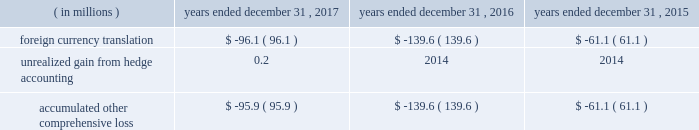Table of contents cdw corporation and subsidiaries method or straight-line method , as applicable .
The company classifies deferred financing costs as a direct deduction from the carrying value of the long-term debt liability on the consolidated balance sheets , except for deferred financing costs associated with revolving credit facilities which are presented as an asset , within other assets on the consolidated balance sheets .
Derivative instruments the company has interest rate cap agreements for the purpose of hedging its exposure to fluctuations in interest rates .
The interest rate cap agreements are designated as cash flow hedges of interest rate risk and recorded at fair value in other assets on the consolidated balance sheets .
The gain or loss on the derivative instruments is reported as a component of accumulated other comprehensive loss until reclassified to interest expense in the same period the hedge transaction affects earnings .
Fair value measurements fair value is defined under gaap as the price that would be received to sell an asset or paid to transfer a liability in an orderly transaction between market participants at the measurement date .
A fair value hierarchy has been established for valuation inputs to prioritize the inputs into three levels based on the extent to which inputs used in measuring fair value are observable in the market .
Each fair value measurement is reported in one of the three levels which is determined by the lowest level input that is significant to the fair value measurement in its entirety .
These levels are : level 1 2013 observable inputs such as quoted prices for identical instruments traded in active markets .
Level 2 2013 inputs are based on quoted prices for similar instruments in active markets , quoted prices for identical or similar instruments in markets that are not active and model-based valuation techniques for which all significant assumptions are observable in the market or can be corroborated by observable market data for substantially the full term of the assets or liabilities .
Level 3 2013 inputs are generally unobservable and typically reflect management 2019s estimates of assumptions that market participants would use in pricing the asset or liability .
The fair values are therefore determined using model-based techniques that include option pricing models , discounted cash flow models and similar techniques .
Accumulated other comprehensive loss the components of accumulated other comprehensive loss included in stockholders 2019 equity are as follows: .
Revenue recognition the company is a primary distribution channel for a large group of vendors and suppliers , including original equipment manufacturers ( 201coems 201d ) , software publishers , wholesale distributors and cloud providers .
The company records revenue from sales transactions when title and risk of loss are passed to the customer , there is persuasive evidence of an arrangement for sale , delivery has occurred and/or services have been rendered , the sales price is fixed or determinable , and collectability is reasonably assured .
The company 2019s shipping terms typically specify f.o.b .
Destination , at which time title and risk of loss have passed to the customer .
Revenues from the sales of hardware products and software licenses are generally recognized on a gross basis with the selling price to the customer recorded as sales and the acquisition cost of the product recorded as cost of sales .
These items can be delivered to customers in a variety of ways , including ( i ) as physical product shipped from the company 2019s warehouse , ( ii ) via drop-shipment by the vendor or supplier , or ( iii ) via electronic delivery for software licenses .
At the time of sale , the company records an estimate for sales returns and allowances based on historical experience .
The company 2019s vendor partners warrant most of the products the company sells .
The company leverages drop-shipment arrangements with many of its vendors and suppliers to deliver products to its customers without having to physically hold the inventory at its warehouses , thereby increasing efficiency and reducing .
In millions , what was the average loss from foreign currency translation from 2015-2017? 
Rationale: add all losses from foreign transactions and divide by the total number of years to get the average .
Computations: (((96.1 + 139.6) + 61.1) / 3)
Answer: 98.93333. 